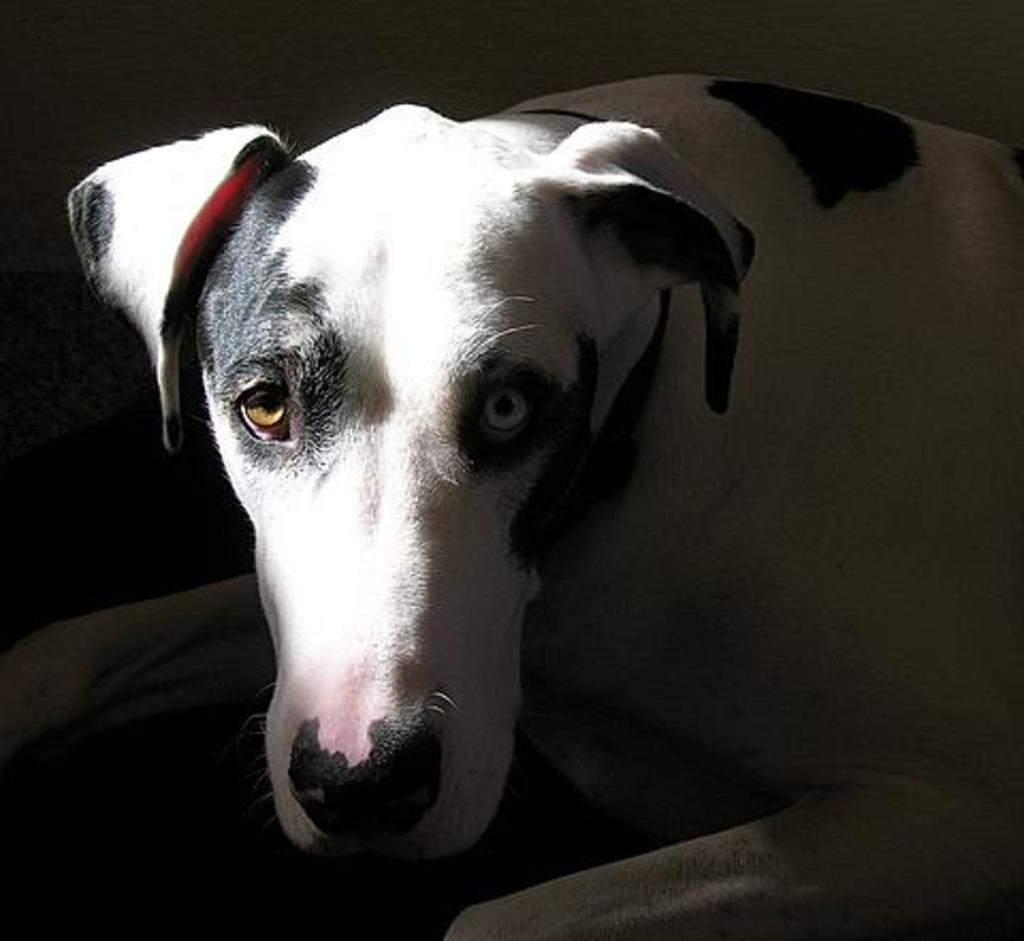What type of animal is present in the image? There is a dog in the image. What type of hose is the dog using to water the plants in the image? There is no hose present in the image, and the dog is not shown watering any plants. What sound does the bell make when the dog rings it in the image? There is no bell present in the image, and the dog is not shown ringing any bell. 